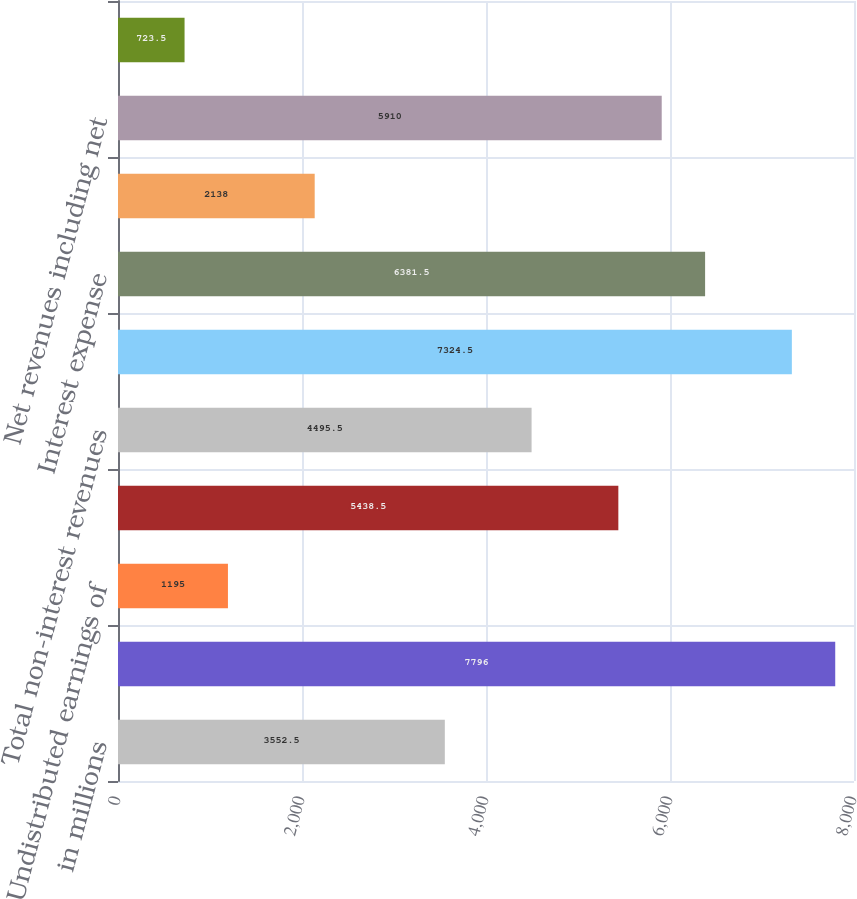Convert chart to OTSL. <chart><loc_0><loc_0><loc_500><loc_500><bar_chart><fcel>in millions<fcel>Dividends from nonbank<fcel>Undistributed earnings of<fcel>Other revenues<fcel>Total non-interest revenues<fcel>Interest income<fcel>Interest expense<fcel>Net interest income/(expense)<fcel>Net revenues including net<fcel>Compensation and benefits<nl><fcel>3552.5<fcel>7796<fcel>1195<fcel>5438.5<fcel>4495.5<fcel>7324.5<fcel>6381.5<fcel>2138<fcel>5910<fcel>723.5<nl></chart> 